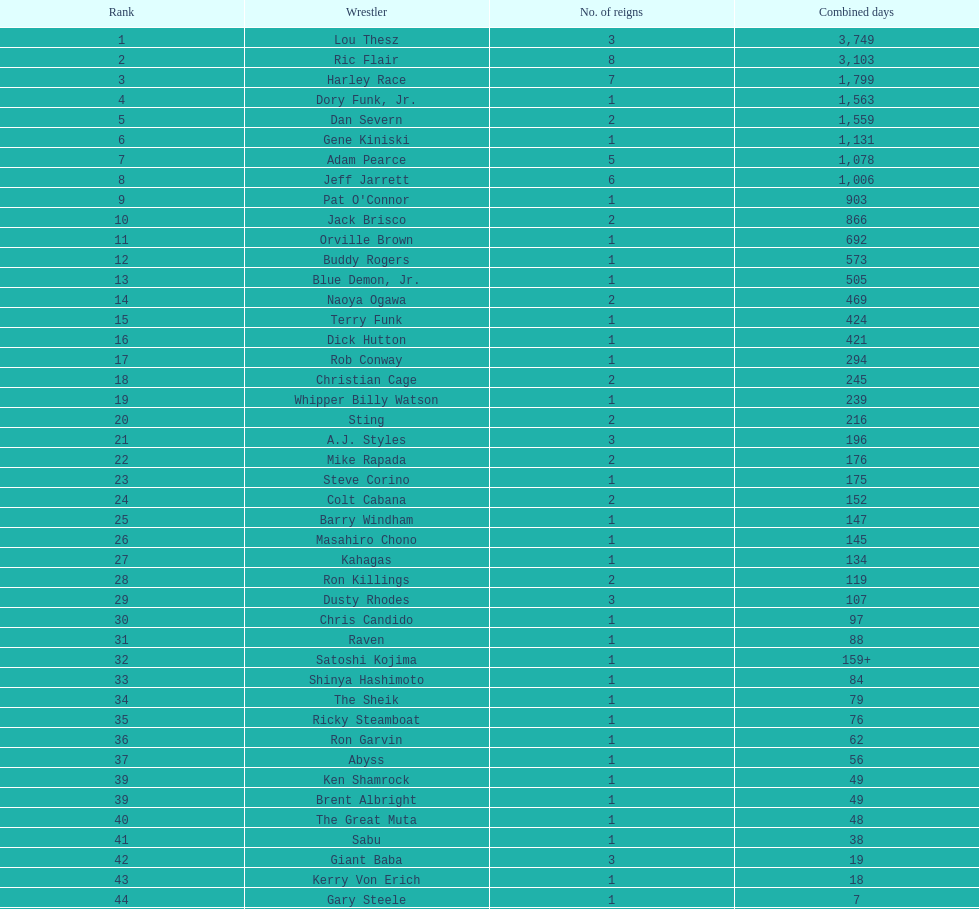How long did orville brown remain nwa world heavyweight champion? 692 days. 